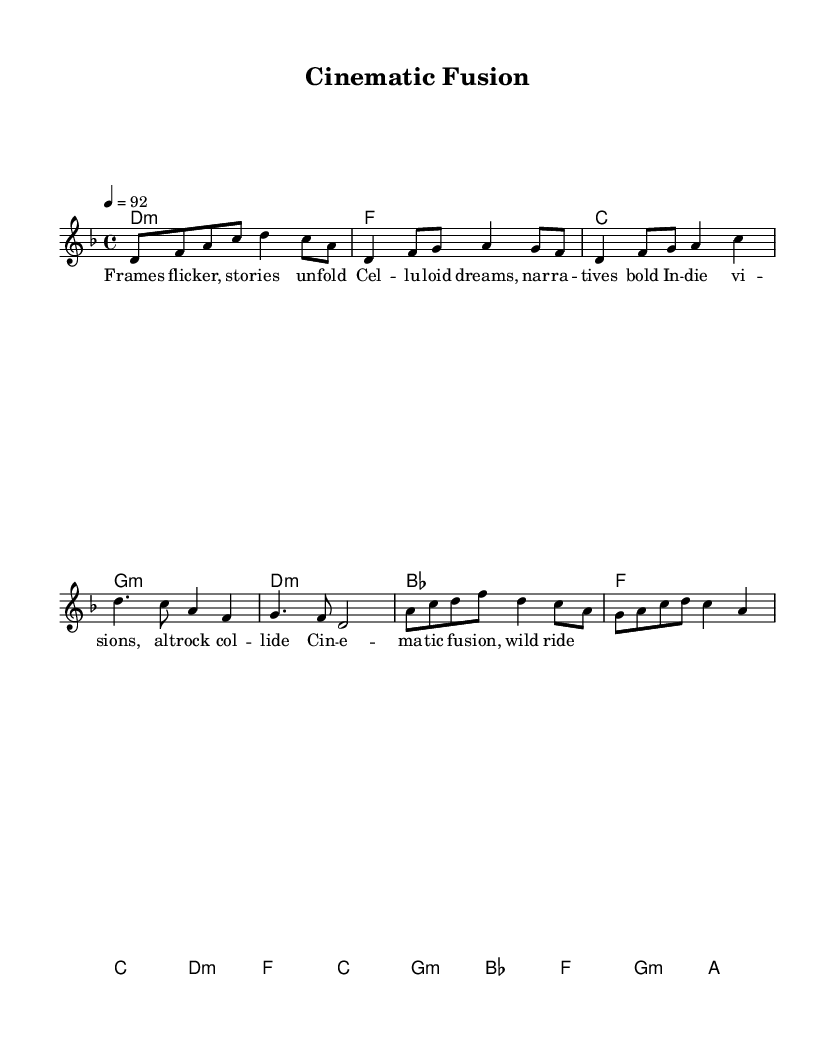What is the key signature of this music? The key signature is D minor, indicated by the presence of one flat (B flat) shown at the beginning of the score near the clef.
Answer: D minor What is the time signature of this music? The time signature is 4/4, which indicates there are four beats per measure and the quarter note gets one beat. This is shown at the beginning of the score.
Answer: 4/4 What is the tempo marking of the music? The tempo marking is 92 BPM (beats per minute), indicating the speed at which the piece should be played. This is stated in the tempo indication at the beginning of the score.
Answer: 92 How many measures are in the verse section? The verse section consists of 4 measures, as indicated by the notation that corresponds to the verse lyrics in the music.
Answer: 4 What type of musical form is represented in this piece? The piece follows a verse-chorus-bridge structure, commonly found in songs but tailored to the context of indie-rap, emphasizing thematic development across sections. The layout of the lyrics and music clearly shows these distinct parts.
Answer: Verse-chorus-bridge What genre fusion is represented by this piece? The piece represents a fusion of indie rap and alternative rock, as indicated by the collaboration nature in the theme of the lyrics and music structure, aligning with the genre's stylistic elements.
Answer: Indie rap and alternative rock How many different chords are used in the harmony section? There are five unique chords used in the harmony section: D minor, F major, C major, G minor, and B flat major, as shown in the chord notation corresponding to the musical sections.
Answer: Five 